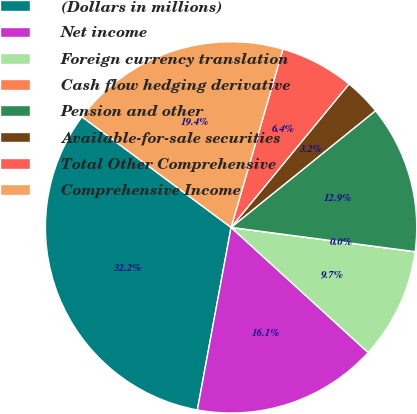<chart> <loc_0><loc_0><loc_500><loc_500><pie_chart><fcel>(Dollars in millions)<fcel>Net income<fcel>Foreign currency translation<fcel>Cash flow hedging derivative<fcel>Pension and other<fcel>Available-for-sale securities<fcel>Total Other Comprehensive<fcel>Comprehensive Income<nl><fcel>32.25%<fcel>16.13%<fcel>9.68%<fcel>0.01%<fcel>12.9%<fcel>3.23%<fcel>6.45%<fcel>19.35%<nl></chart> 